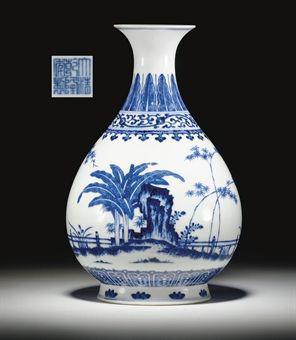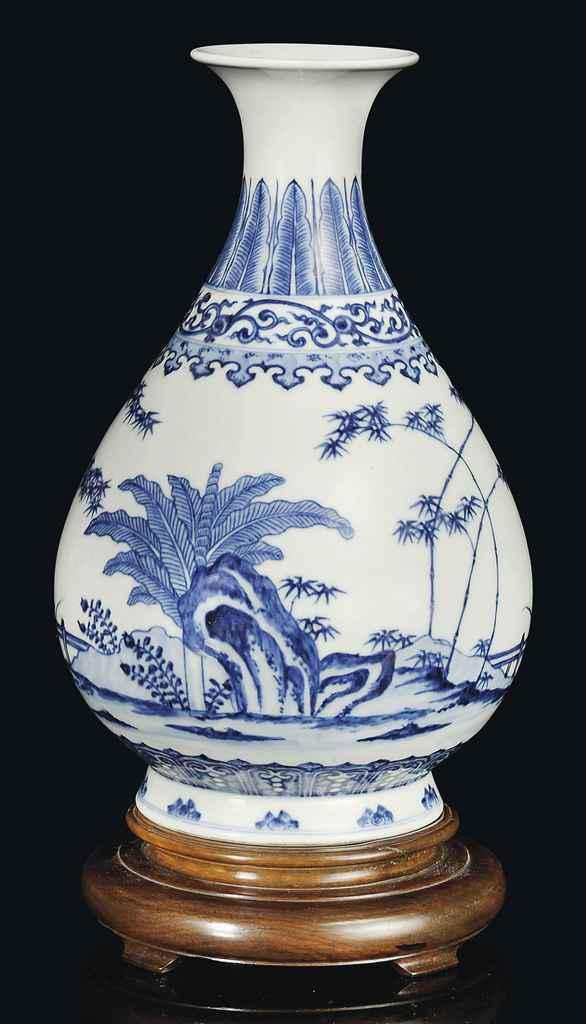The first image is the image on the left, the second image is the image on the right. For the images shown, is this caption "In the left image, the artwork appears to include a dragon." true? Answer yes or no. No. The first image is the image on the left, the second image is the image on the right. For the images shown, is this caption "The left image features a vase with a round midsection and a dragon depicted in blue on its front." true? Answer yes or no. No. 